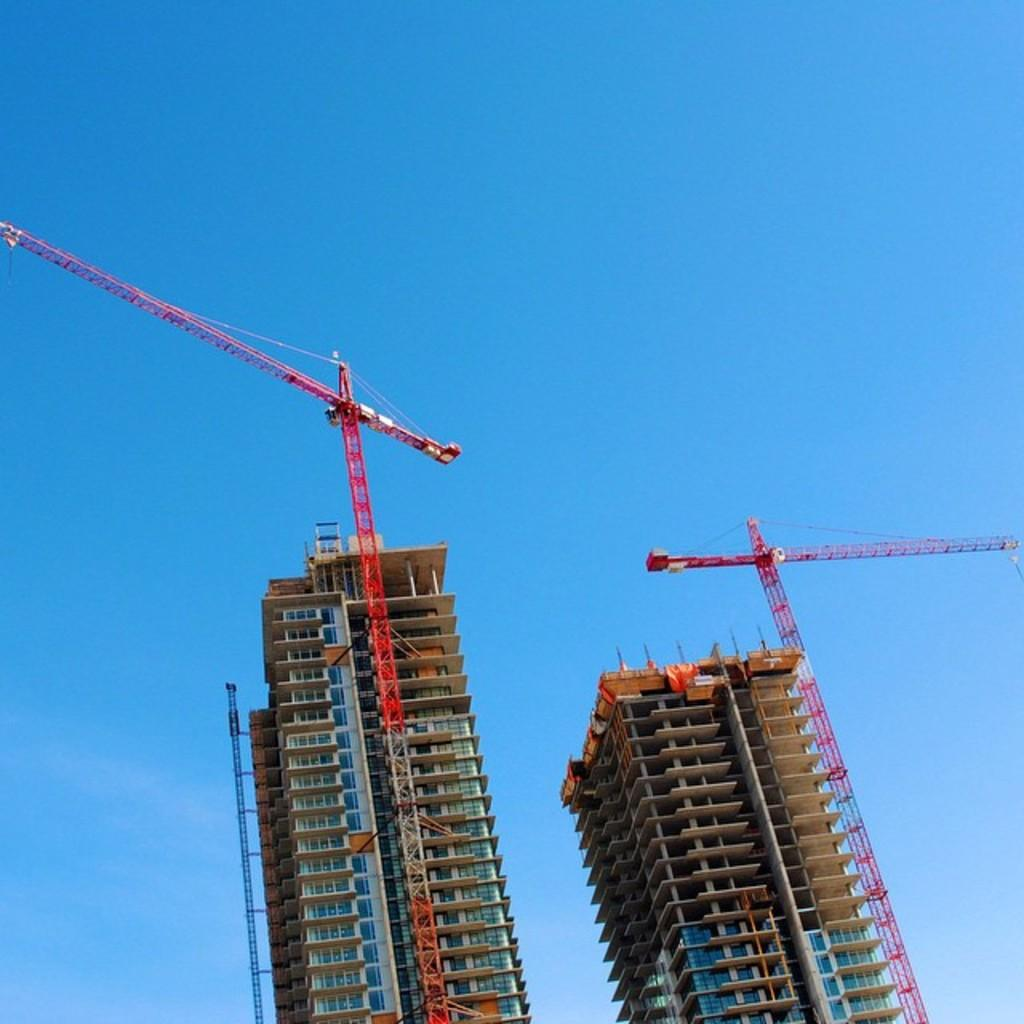What structures can be seen in the image? There are two crane towers in the image. What is happening around the crane towers? There are constructions in the image. What can be seen in the background of the image? The sky is visible in the background of the image. What type of hobbies are the crane towers participating in during the image? Crane towers do not have hobbies, as they are inanimate objects. 